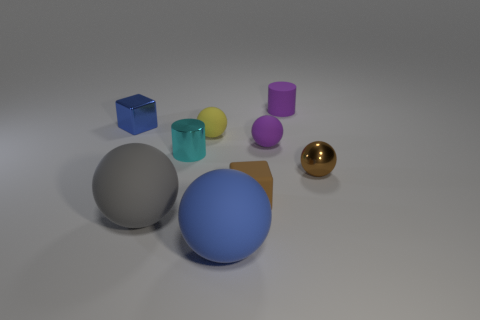There is a matte object in front of the gray thing; is it the same color as the cylinder that is behind the tiny blue metal object?
Make the answer very short. No. There is a small metal sphere; what number of blue balls are on the right side of it?
Provide a succinct answer. 0. There is a large ball that is left of the cylinder that is to the left of the tiny yellow sphere; are there any yellow matte objects to the left of it?
Keep it short and to the point. No. How many blue matte things are the same size as the brown metal ball?
Provide a short and direct response. 0. What material is the cube to the right of the large rubber object behind the blue matte thing?
Ensure brevity in your answer.  Rubber. What shape is the brown object right of the purple thing in front of the shiny thing behind the tiny yellow matte thing?
Offer a terse response. Sphere. There is a blue object that is behind the brown shiny thing; is it the same shape as the large matte object that is on the right side of the yellow rubber object?
Provide a succinct answer. No. What number of other things are there of the same material as the small cyan cylinder
Make the answer very short. 2. There is a large object that is the same material as the large gray sphere; what shape is it?
Provide a short and direct response. Sphere. Do the brown sphere and the cyan cylinder have the same size?
Provide a short and direct response. Yes. 